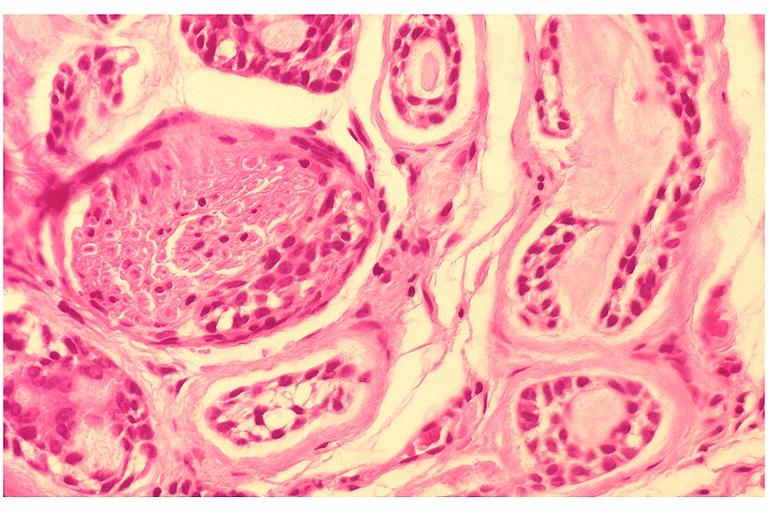what is present?
Answer the question using a single word or phrase. Oral 